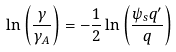<formula> <loc_0><loc_0><loc_500><loc_500>\ln \left ( \frac { \gamma } { \gamma _ { A } } \right ) = - \frac { 1 } { 2 } \ln \left ( \frac { \psi _ { s } q ^ { \prime } } { q } \right )</formula> 